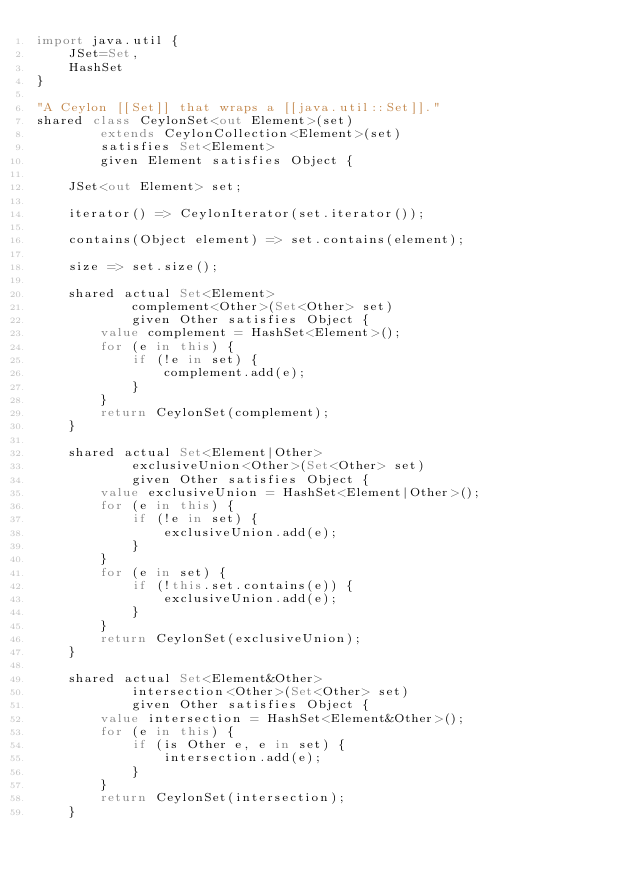<code> <loc_0><loc_0><loc_500><loc_500><_Ceylon_>import java.util {
    JSet=Set,
    HashSet
}

"A Ceylon [[Set]] that wraps a [[java.util::Set]]."
shared class CeylonSet<out Element>(set)
        extends CeylonCollection<Element>(set)
        satisfies Set<Element> 
        given Element satisfies Object {

    JSet<out Element> set;
    
    iterator() => CeylonIterator(set.iterator());
    
    contains(Object element) => set.contains(element);

    size => set.size();

    shared actual Set<Element> 
            complement<Other>(Set<Other> set)
            given Other satisfies Object {
        value complement = HashSet<Element>();
        for (e in this) {
            if (!e in set) {
                complement.add(e);
            }
        }
        return CeylonSet(complement);
    }
    
    shared actual Set<Element|Other> 
            exclusiveUnion<Other>(Set<Other> set)
            given Other satisfies Object {
        value exclusiveUnion = HashSet<Element|Other>();
        for (e in this) {
            if (!e in set) {
                exclusiveUnion.add(e);
            }
        }
        for (e in set) {
            if (!this.set.contains(e)) {
                exclusiveUnion.add(e);
            }
        }
        return CeylonSet(exclusiveUnion);
    }
    
    shared actual Set<Element&Other> 
            intersection<Other>(Set<Other> set)
            given Other satisfies Object {
        value intersection = HashSet<Element&Other>();
        for (e in this) {
            if (is Other e, e in set) {
                intersection.add(e);
            }
        }
        return CeylonSet(intersection);
    }
    </code> 